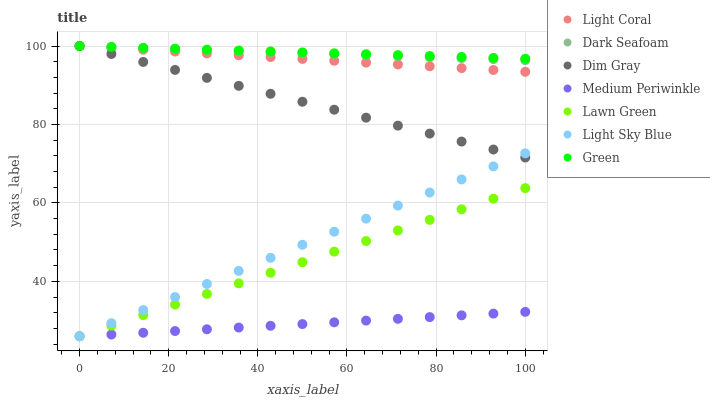Does Medium Periwinkle have the minimum area under the curve?
Answer yes or no. Yes. Does Green have the maximum area under the curve?
Answer yes or no. Yes. Does Dim Gray have the minimum area under the curve?
Answer yes or no. No. Does Dim Gray have the maximum area under the curve?
Answer yes or no. No. Is Medium Periwinkle the smoothest?
Answer yes or no. Yes. Is Green the roughest?
Answer yes or no. Yes. Is Dim Gray the smoothest?
Answer yes or no. No. Is Dim Gray the roughest?
Answer yes or no. No. Does Lawn Green have the lowest value?
Answer yes or no. Yes. Does Dim Gray have the lowest value?
Answer yes or no. No. Does Green have the highest value?
Answer yes or no. Yes. Does Medium Periwinkle have the highest value?
Answer yes or no. No. Is Medium Periwinkle less than Dark Seafoam?
Answer yes or no. Yes. Is Dim Gray greater than Lawn Green?
Answer yes or no. Yes. Does Dark Seafoam intersect Green?
Answer yes or no. Yes. Is Dark Seafoam less than Green?
Answer yes or no. No. Is Dark Seafoam greater than Green?
Answer yes or no. No. Does Medium Periwinkle intersect Dark Seafoam?
Answer yes or no. No. 